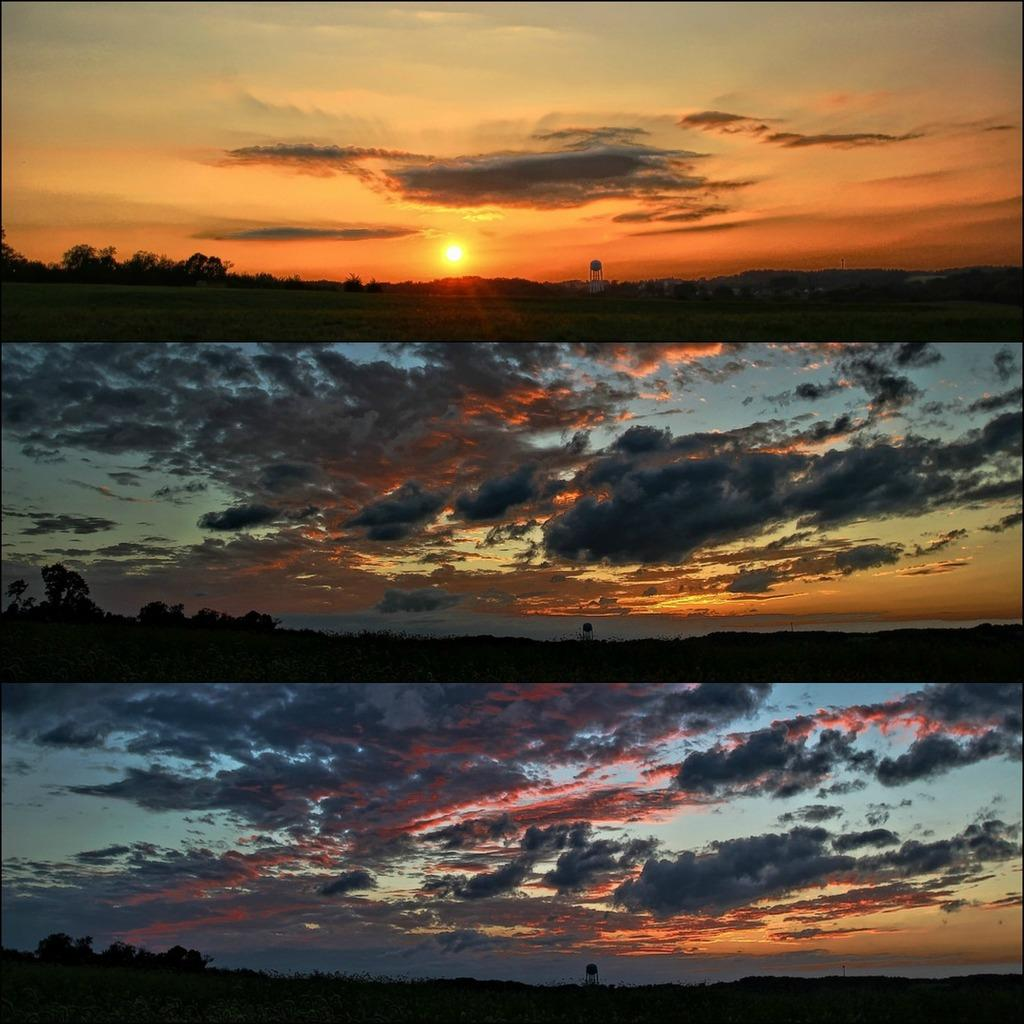What can be seen in the background of the first picture? The first picture has the sun and trees in the background. What is the ground made of in the first picture? The ground in the first picture is greenery. What is common between the second and third pictures? The second and third pictures have trees and a cloudy sky. What type of nerve can be seen in the second picture? There are no nerves present in the second picture; it features trees and a cloudy sky. Is there a sign visible in any of the pictures? There is no sign visible in any of the pictures. 